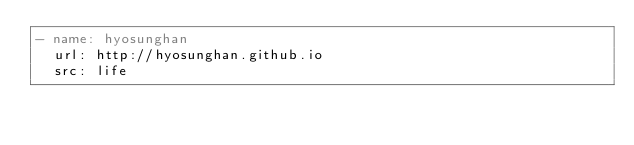Convert code to text. <code><loc_0><loc_0><loc_500><loc_500><_YAML_>- name: hyosunghan
  url: http://hyosunghan.github.io
  src: life

</code> 